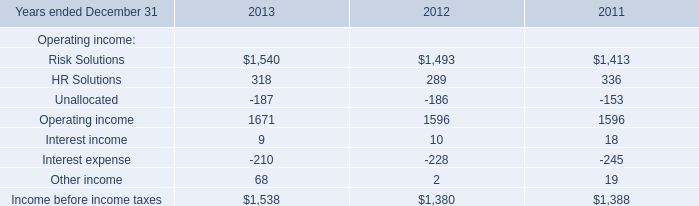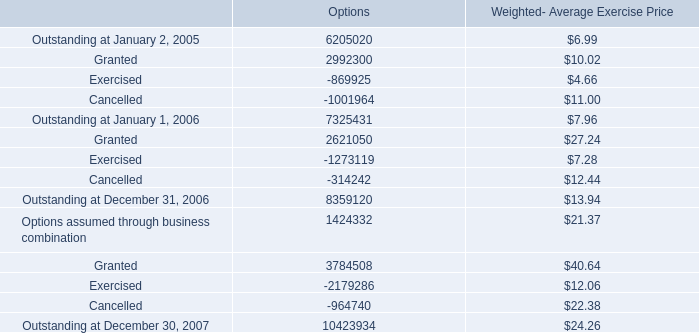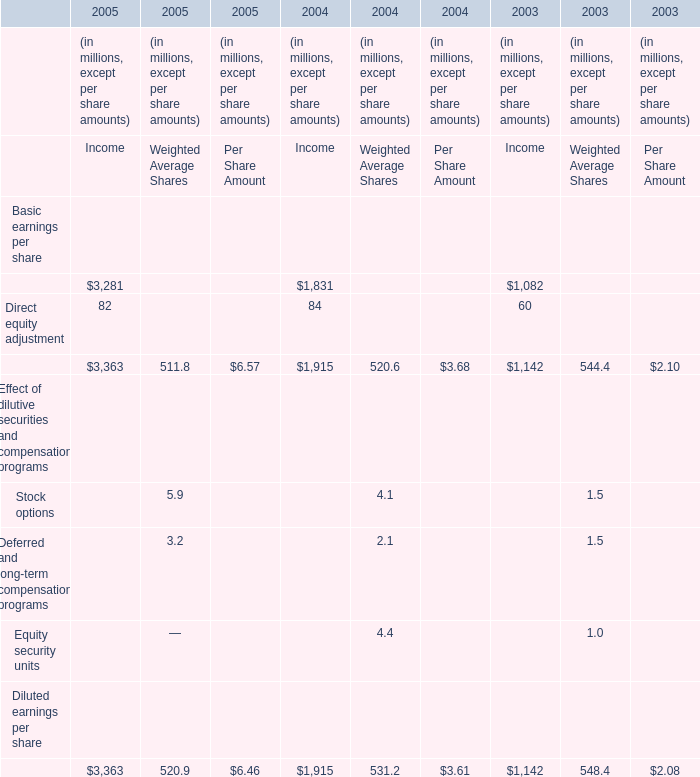What is the average amount of Operating income of 2013, and Outstanding at January 2, 2005 of Options ? 
Computations: ((1671.0 + 6205020.0) / 2)
Answer: 3103345.5. 